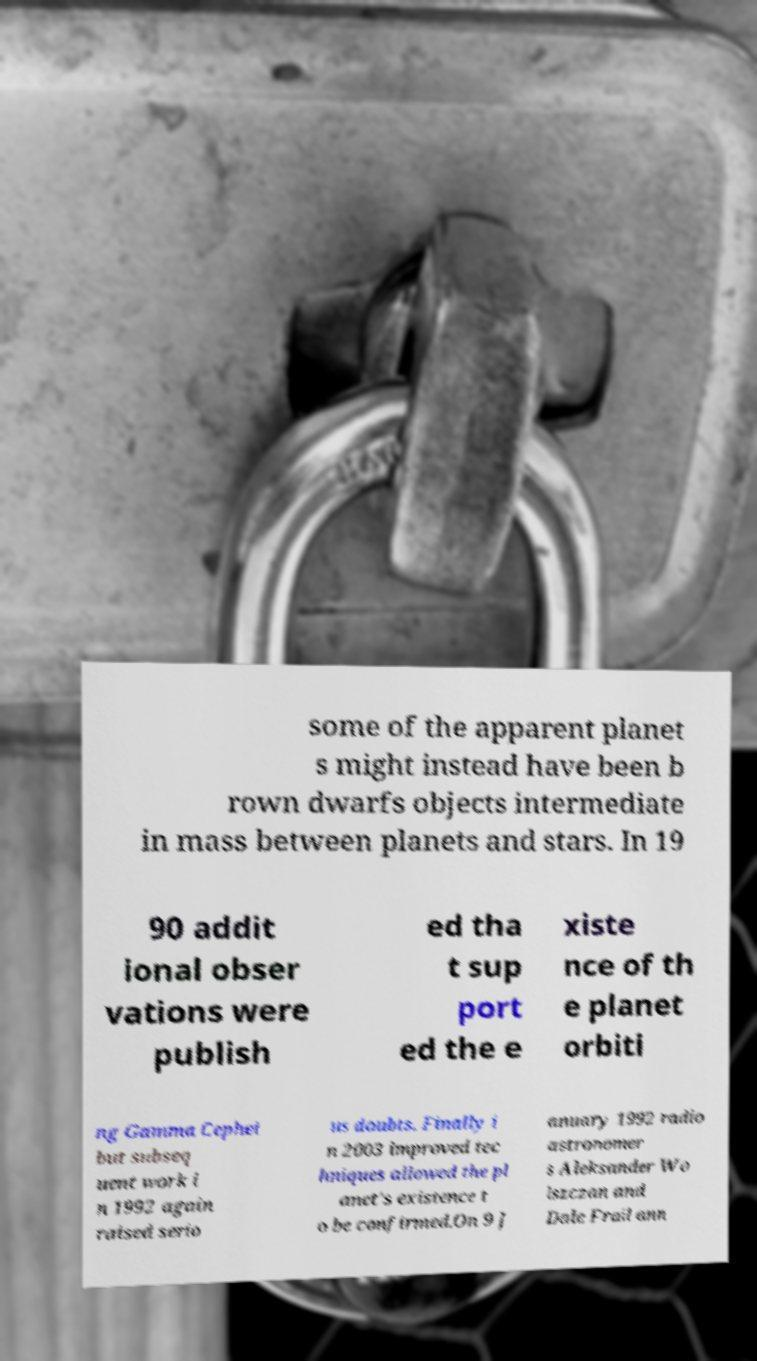Please read and relay the text visible in this image. What does it say? some of the apparent planet s might instead have been b rown dwarfs objects intermediate in mass between planets and stars. In 19 90 addit ional obser vations were publish ed tha t sup port ed the e xiste nce of th e planet orbiti ng Gamma Cephei but subseq uent work i n 1992 again raised serio us doubts. Finally i n 2003 improved tec hniques allowed the pl anet's existence t o be confirmed.On 9 J anuary 1992 radio astronomer s Aleksander Wo lszczan and Dale Frail ann 